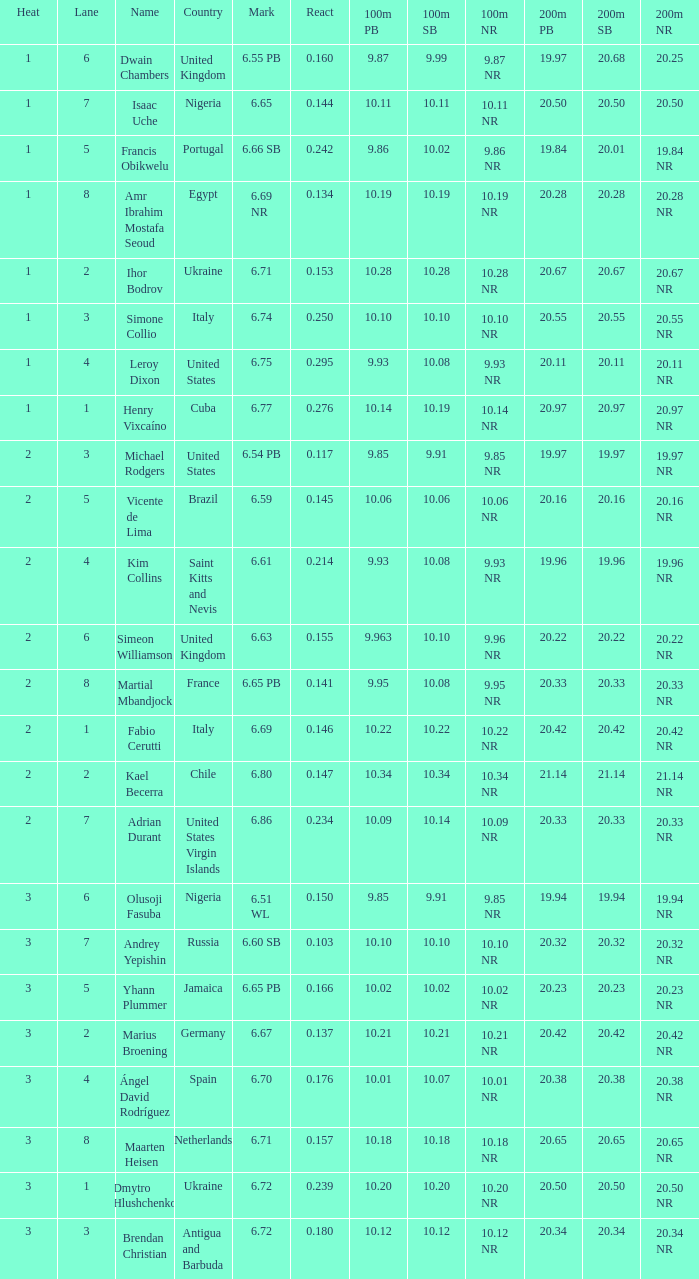What is Heat, when Mark is 6.69? 2.0. I'm looking to parse the entire table for insights. Could you assist me with that? {'header': ['Heat', 'Lane', 'Name', 'Country', 'Mark', 'React', '100m PB', '100m SB', '100m NR', '200m PB', '200m SB', '200m NR'], 'rows': [['1', '6', 'Dwain Chambers', 'United Kingdom', '6.55 PB', '0.160', '9.87', '9.99', '9.87 NR', '19.97', '20.68', '20.25'], ['1', '7', 'Isaac Uche', 'Nigeria', '6.65', '0.144', '10.11', '10.11', '10.11 NR', '20.50', '20.50', '20.50'], ['1', '5', 'Francis Obikwelu', 'Portugal', '6.66 SB', '0.242', '9.86', '10.02', '9.86 NR', '19.84', '20.01', '19.84 NR'], ['1', '8', 'Amr Ibrahim Mostafa Seoud', 'Egypt', '6.69 NR', '0.134', '10.19', '10.19', '10.19 NR', '20.28', '20.28', '20.28 NR'], ['1', '2', 'Ihor Bodrov', 'Ukraine', '6.71', '0.153', '10.28', '10.28', '10.28 NR', '20.67', '20.67', '20.67 NR'], ['1', '3', 'Simone Collio', 'Italy', '6.74', '0.250', '10.10', '10.10', '10.10 NR', '20.55', '20.55', '20.55 NR'], ['1', '4', 'Leroy Dixon', 'United States', '6.75', '0.295', '9.93', '10.08', '9.93 NR', '20.11', '20.11', '20.11 NR'], ['1', '1', 'Henry Vixcaíno', 'Cuba', '6.77', '0.276', '10.14', '10.19', '10.14 NR', '20.97', '20.97', '20.97 NR'], ['2', '3', 'Michael Rodgers', 'United States', '6.54 PB', '0.117', '9.85', '9.91', '9.85 NR', '19.97', '19.97', '19.97 NR'], ['2', '5', 'Vicente de Lima', 'Brazil', '6.59', '0.145', '10.06', '10.06', '10.06 NR', '20.16', '20.16', '20.16 NR'], ['2', '4', 'Kim Collins', 'Saint Kitts and Nevis', '6.61', '0.214', '9.93', '10.08', '9.93 NR', '19.96', '19.96', '19.96 NR'], ['2', '6', 'Simeon Williamson', 'United Kingdom', '6.63', '0.155', '9.963', '10.10', '9.96 NR', '20.22', '20.22', '20.22 NR'], ['2', '8', 'Martial Mbandjock', 'France', '6.65 PB', '0.141', '9.95', '10.08', '9.95 NR', '20.33', '20.33', '20.33 NR'], ['2', '1', 'Fabio Cerutti', 'Italy', '6.69', '0.146', '10.22', '10.22', '10.22 NR', '20.42', '20.42', '20.42 NR'], ['2', '2', 'Kael Becerra', 'Chile', '6.80', '0.147', '10.34', '10.34', '10.34 NR', '21.14', '21.14', '21.14 NR'], ['2', '7', 'Adrian Durant', 'United States Virgin Islands', '6.86', '0.234', '10.09', '10.14', '10.09 NR', '20.33', '20.33', '20.33 NR'], ['3', '6', 'Olusoji Fasuba', 'Nigeria', '6.51 WL', '0.150', '9.85', '9.91', '9.85 NR', '19.94', '19.94', '19.94 NR'], ['3', '7', 'Andrey Yepishin', 'Russia', '6.60 SB', '0.103', '10.10', '10.10', '10.10 NR', '20.32', '20.32', '20.32 NR'], ['3', '5', 'Yhann Plummer', 'Jamaica', '6.65 PB', '0.166', '10.02', '10.02', '10.02 NR', '20.23', '20.23', '20.23 NR'], ['3', '2', 'Marius Broening', 'Germany', '6.67', '0.137', '10.21', '10.21', '10.21 NR', '20.42', '20.42', '20.42 NR'], ['3', '4', 'Ángel David Rodríguez', 'Spain', '6.70', '0.176', '10.01', '10.07', '10.01 NR', '20.38', '20.38', '20.38 NR'], ['3', '8', 'Maarten Heisen', 'Netherlands', '6.71', '0.157', '10.18', '10.18', '10.18 NR', '20.65', '20.65', '20.65 NR'], ['3', '1', 'Dmytro Hlushchenko', 'Ukraine', '6.72', '0.239', '10.20', '10.20', '10.20 NR', '20.50', '20.50', '20.50 NR'], ['3', '3', 'Brendan Christian', 'Antigua and Barbuda', '6.72', '0.180', '10.12', '10.12', '10.12 NR', '20.34', '20.34', '20.34 NR']]} 